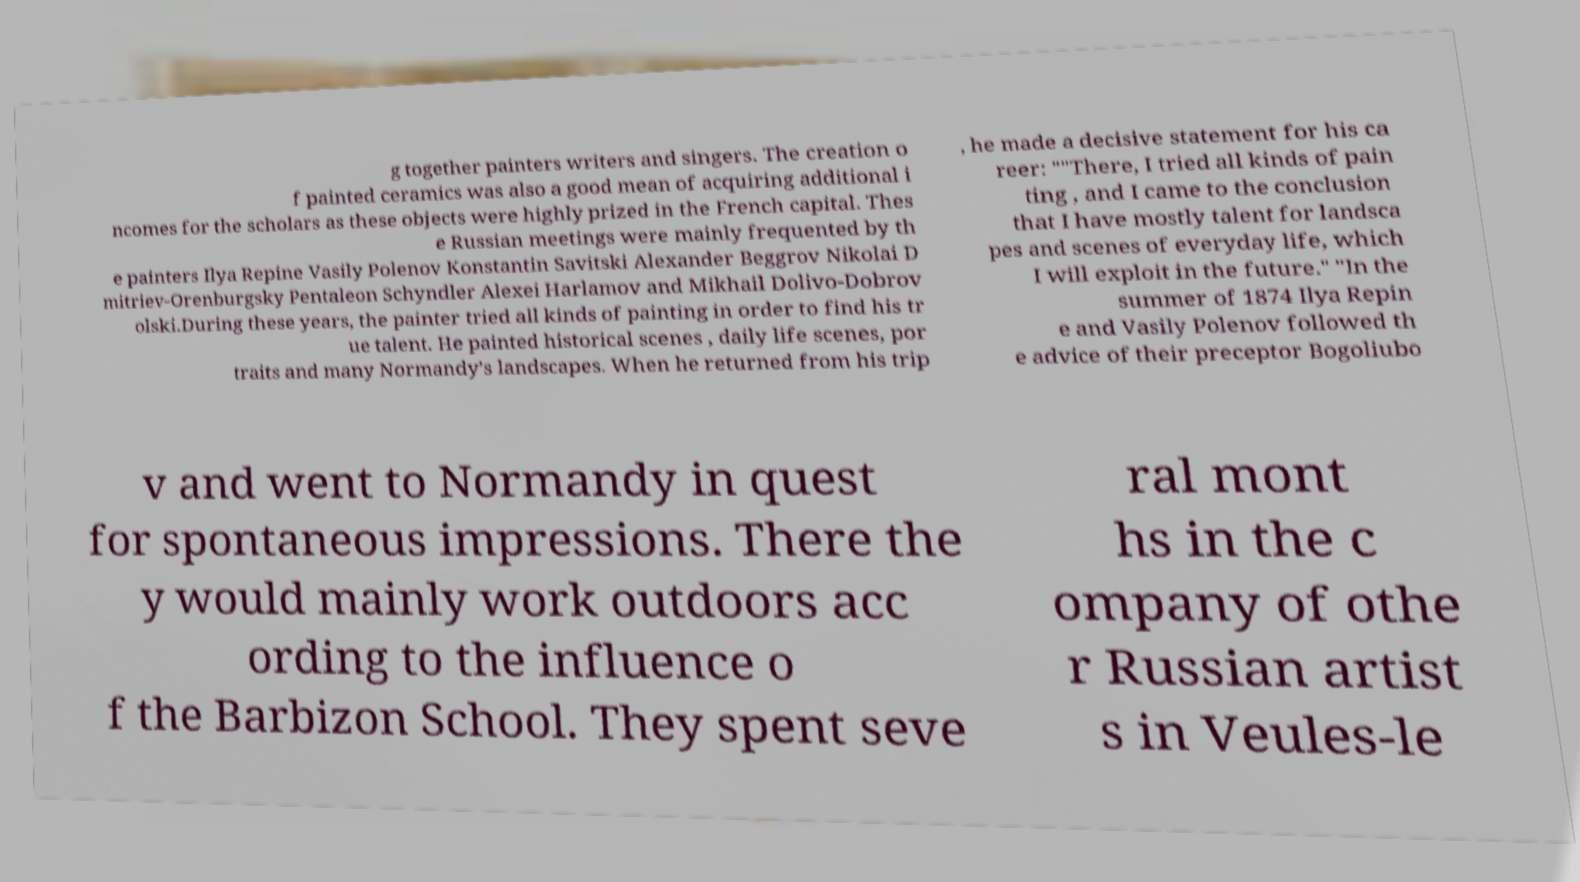Can you read and provide the text displayed in the image?This photo seems to have some interesting text. Can you extract and type it out for me? g together painters writers and singers. The creation o f painted ceramics was also a good mean of acquiring additional i ncomes for the scholars as these objects were highly prized in the French capital. Thes e Russian meetings were mainly frequented by th e painters Ilya Repine Vasily Polenov Konstantin Savitski Alexander Beggrov Nikolai D mitriev-Orenburgsky Pentaleon Schyndler Alexei Harlamov and Mikhail Dolivo-Dobrov olski.During these years, the painter tried all kinds of painting in order to find his tr ue talent. He painted historical scenes , daily life scenes, por traits and many Normandy’s landscapes. When he returned from his trip , he made a decisive statement for his ca reer: ""There, I tried all kinds of pain ting , and I came to the conclusion that I have mostly talent for landsca pes and scenes of everyday life, which I will exploit in the future." "In the summer of 1874 Ilya Repin e and Vasily Polenov followed th e advice of their preceptor Bogoliubo v and went to Normandy in quest for spontaneous impressions. There the y would mainly work outdoors acc ording to the influence o f the Barbizon School. They spent seve ral mont hs in the c ompany of othe r Russian artist s in Veules-le 